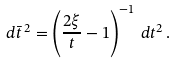Convert formula to latex. <formula><loc_0><loc_0><loc_500><loc_500>d \bar { t } ^ { \, 2 } = \left ( \frac { 2 \xi } { t } - 1 \right ) ^ { - 1 } \, d t ^ { 2 } \, .</formula> 